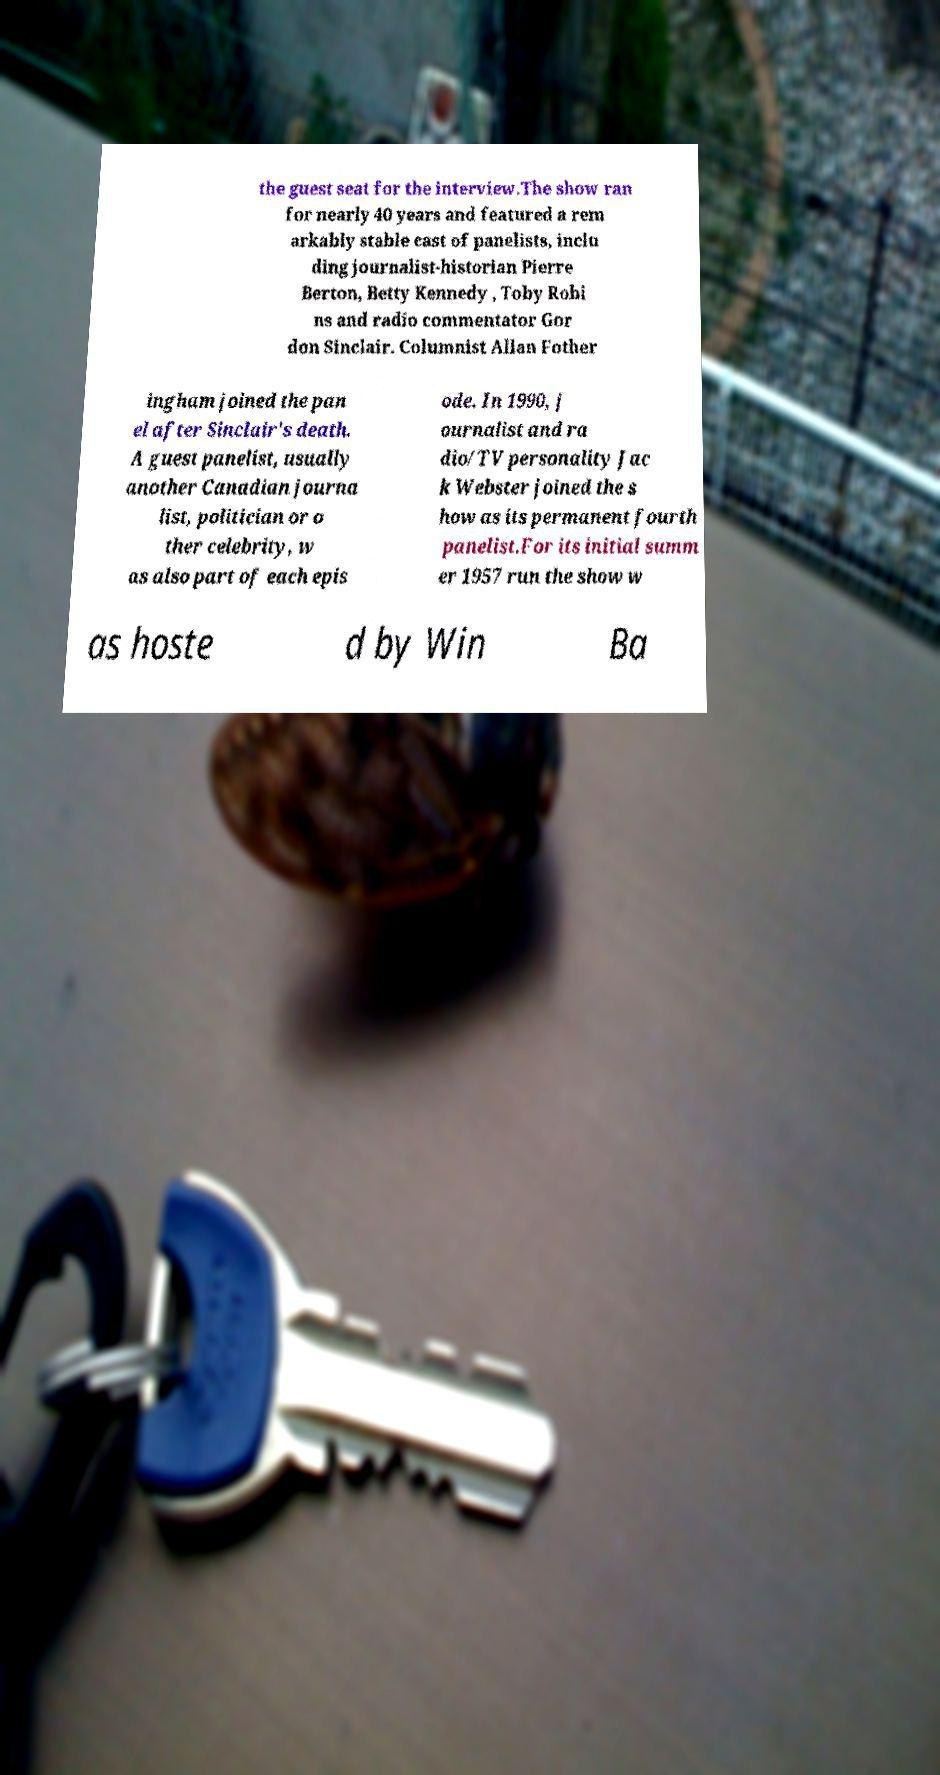Please read and relay the text visible in this image. What does it say? the guest seat for the interview.The show ran for nearly 40 years and featured a rem arkably stable cast of panelists, inclu ding journalist-historian Pierre Berton, Betty Kennedy , Toby Robi ns and radio commentator Gor don Sinclair. Columnist Allan Fother ingham joined the pan el after Sinclair's death. A guest panelist, usually another Canadian journa list, politician or o ther celebrity, w as also part of each epis ode. In 1990, j ournalist and ra dio/TV personality Jac k Webster joined the s how as its permanent fourth panelist.For its initial summ er 1957 run the show w as hoste d by Win Ba 